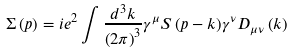<formula> <loc_0><loc_0><loc_500><loc_500>\Sigma \left ( { p } \right ) = i e ^ { 2 } \int { \frac { { d ^ { 3 } k } } { { \left ( { 2 \pi } \right ) ^ { 3 } } } \gamma ^ { \mu } S \left ( { p - k } \right ) } \gamma ^ { \nu } D _ { \mu \nu } \left ( { k } \right )</formula> 